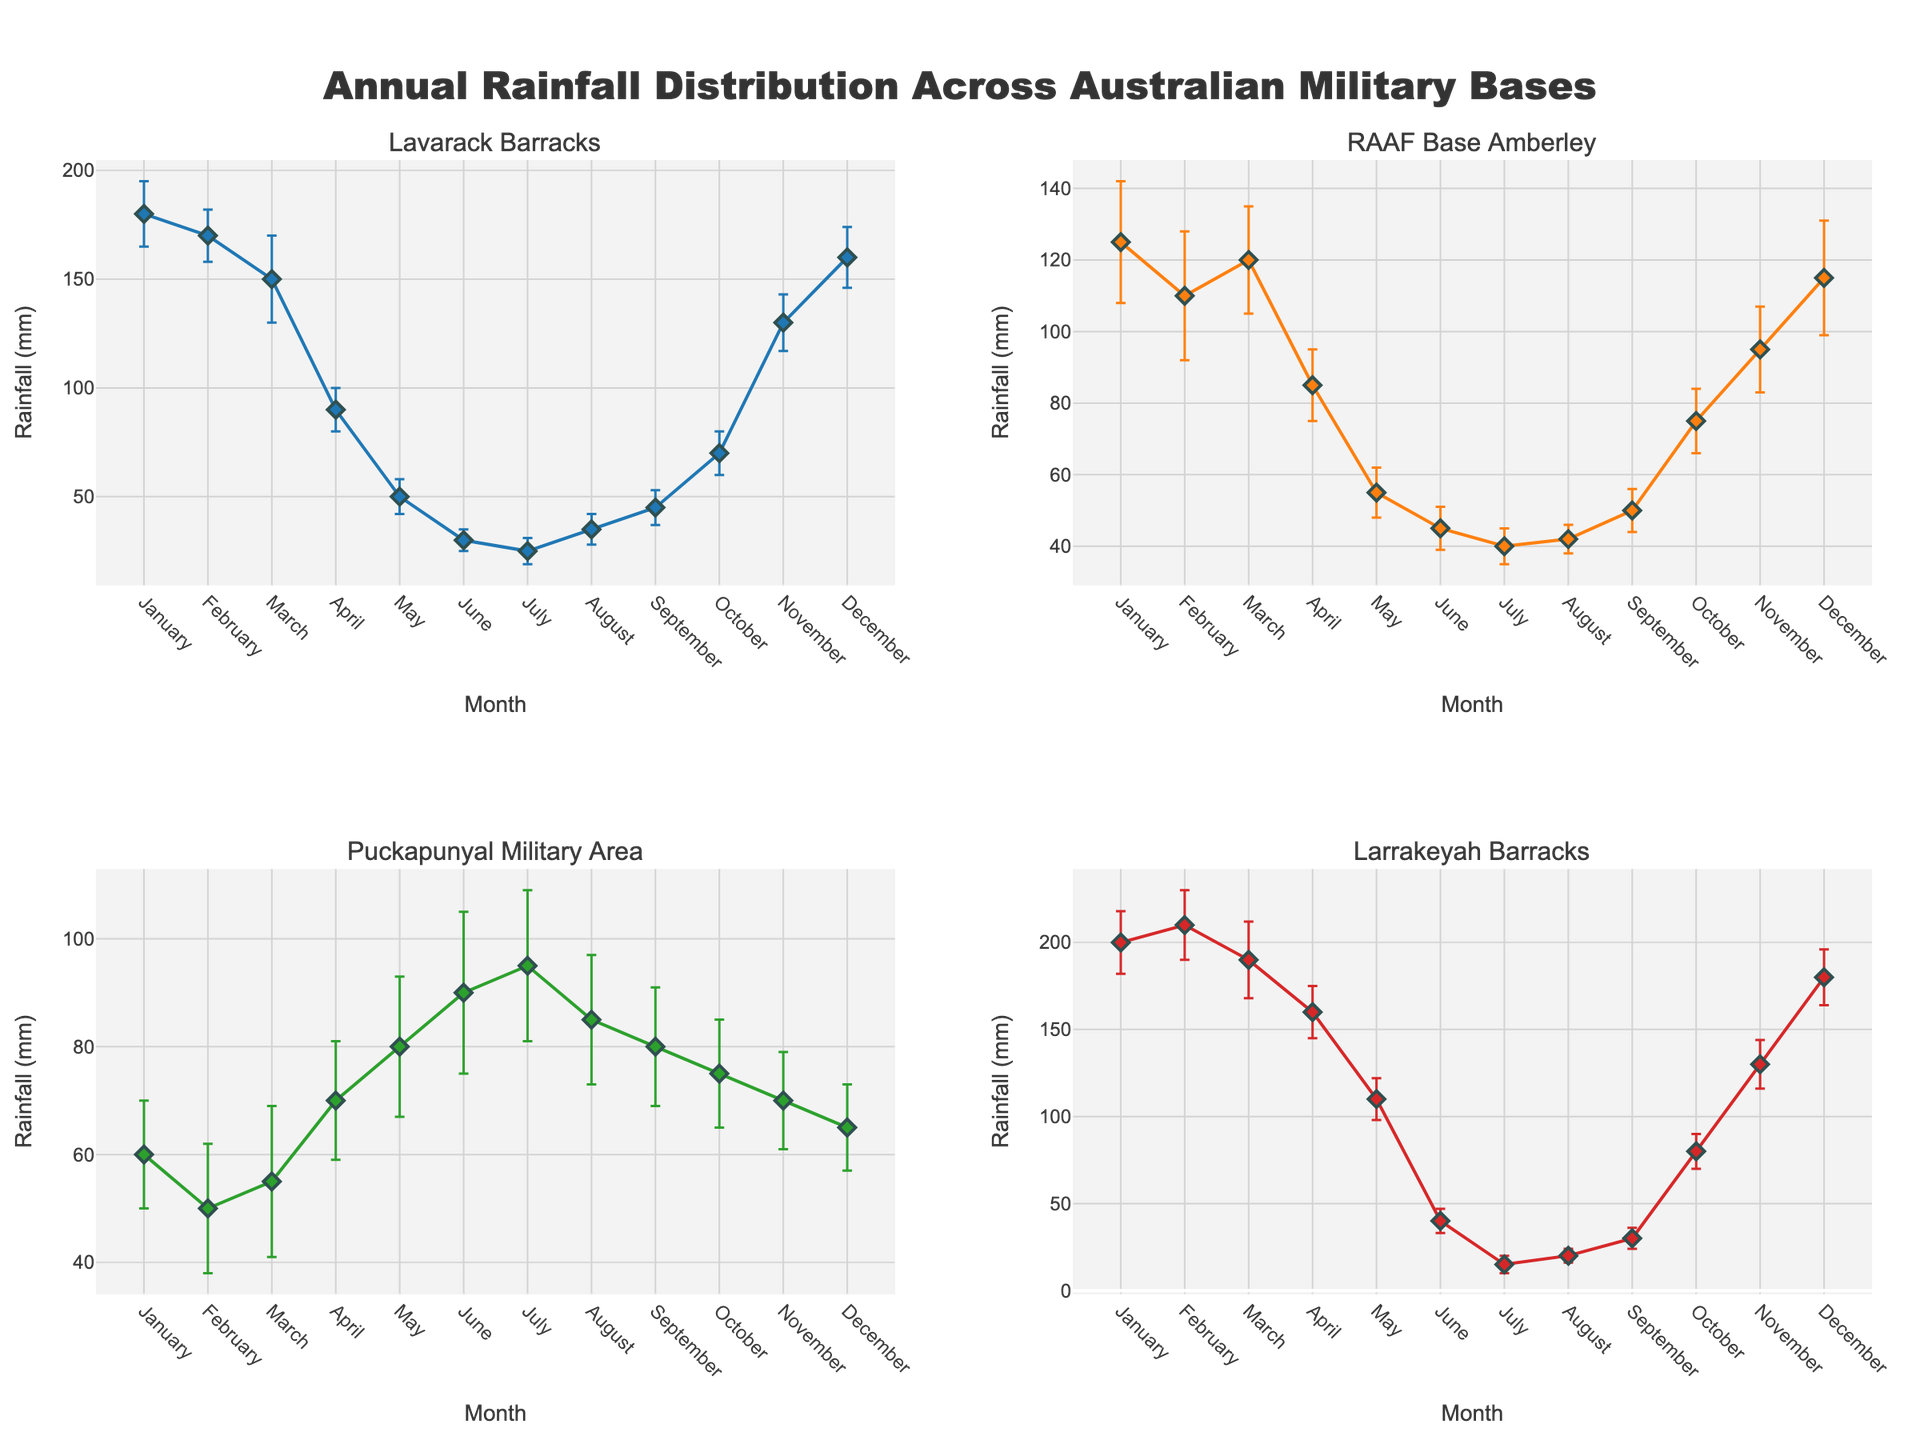What's the title of the figure? The title of the figure is typically placed at the top of the plot. It provides a summary of what the plot is about. Here, it states "Annual Rainfall Distribution Across Australian Military Bases".
Answer: Annual Rainfall Distribution Across Australian Military Bases How many subplots are there in the figure? There are four subplots in the figure, each representing a different military base in Australia. This can be seen by counting the separate sections each with their own title.
Answer: 4 Which base has the highest mean rainfall in January? To answer this, look at the data points for January across all subplots. Larrakeyah Barracks has the highest mean rainfall for January with 200 mm.
Answer: Larrakeyah Barracks What is the range of mean rainfall values for February in Lavarack Barracks? The mean rainfall for Lavarack Barracks in February is 170 mm. The standard deviation is 12 mm, which means the range (mean ± standard deviation) is 158 mm to 182 mm.
Answer: 158-182 mm Which military base experiences the lowest mean rainfall in July? To find this, look at the mean rainfall in July across all subplots. Larrakeyah Barracks has the lowest mean rainfall in July with 15 mm.
Answer: Larrakeyah Barracks Compare the mean rainfall in December between RAAF Base Amberley and Puckapunyal Military Area. Which one has higher mean rainfall? Look at the December mean rainfall values for these two bases. RAAF Base Amberley has 115 mm and Puckapunyal Military Area has 65 mm. RAAF Base Amberley has higher mean rainfall.
Answer: RAAF Base Amberley In which month does RAAF Base Amberley experience the highest mean rainfall? Find the peak of the plot specific to RAAF Base Amberley. The highest mean rainfall for RAAF Base Amberley is in January with 125 mm.
Answer: January What is the mean rainfall in Larrakeyah Barracks in October, and how does its uncertainty compare to that of August? The mean rainfall in Larrakeyah Barracks in October is 80 mm with a standard deviation of 10 mm, while in August it is 20 mm with a standard deviation of 4 mm. The uncertainty (standard deviation) in October is greater.
Answer: 80 mm; greater uncertainty in October When comparing April and May, which month has greater variability in Lavarack Barracks, and what evidence supports that? Variability can be determined by the standard deviation. In Lavarack Barracks, April has a standard deviation of 10 mm while May has 8 mm. Therefore, April has greater variability.
Answer: April; standard deviation is higher Which base shows the most consistent rainfall throughout the year based on the error bars? The consistency can be inferred from the smallest error bars, indicating less variation. Puckapunyal Military Area, with relatively small error bars throughout the year, shows the most consistent rainfall.
Answer: Puckapunyal Military Area 